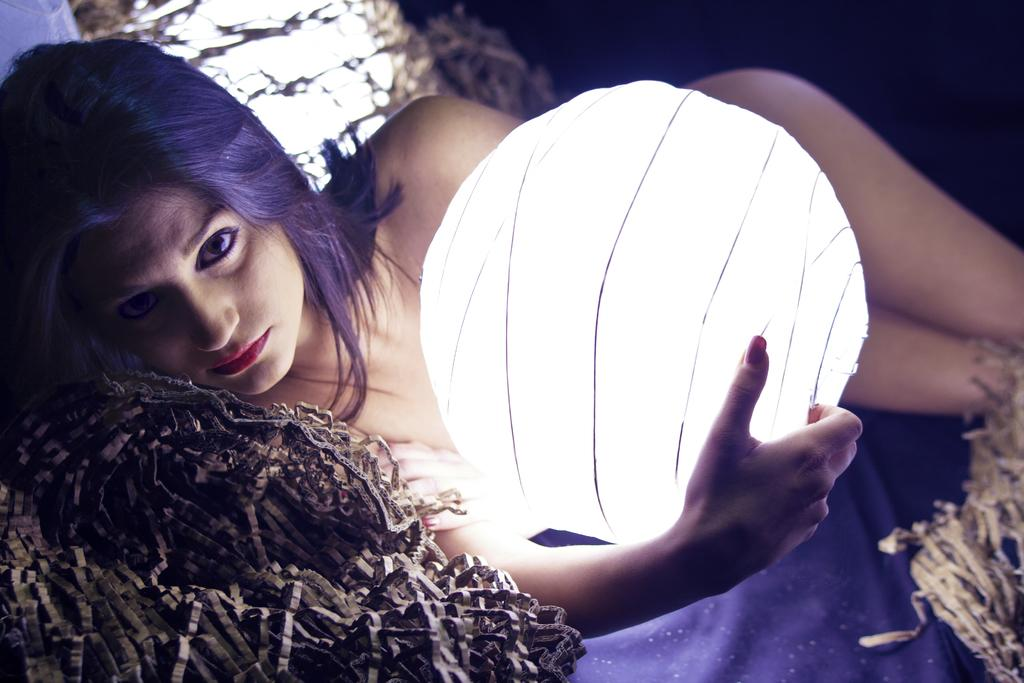Who is the main subject in the image? There is a woman in the image. What is the woman holding in the image? The woman is holding a paper lantern. Can you describe the background of the image? The background of the image is blurry. What does the woman's mouth look like in the image? The provided facts do not mention the woman's mouth, so we cannot determine what it looks like from the image. 